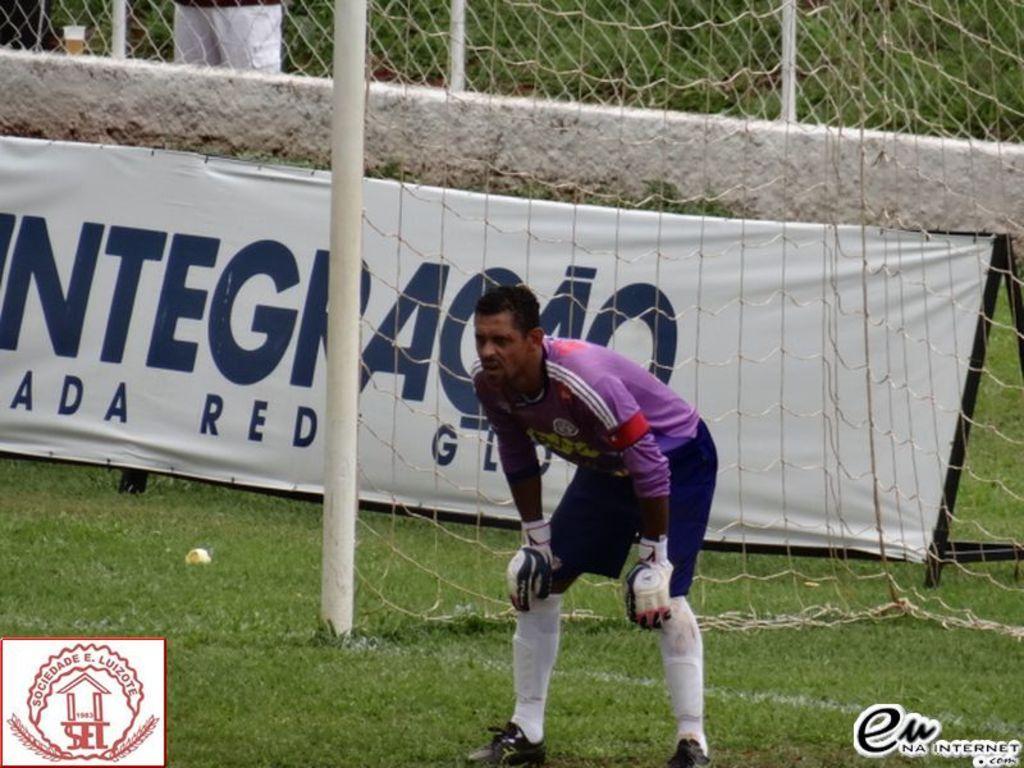Can you describe this image briefly? In the picture we can see a man standing and bending on the grass surface, behind him we can see a net with a pole and behind it we can see the banner near the wall. 